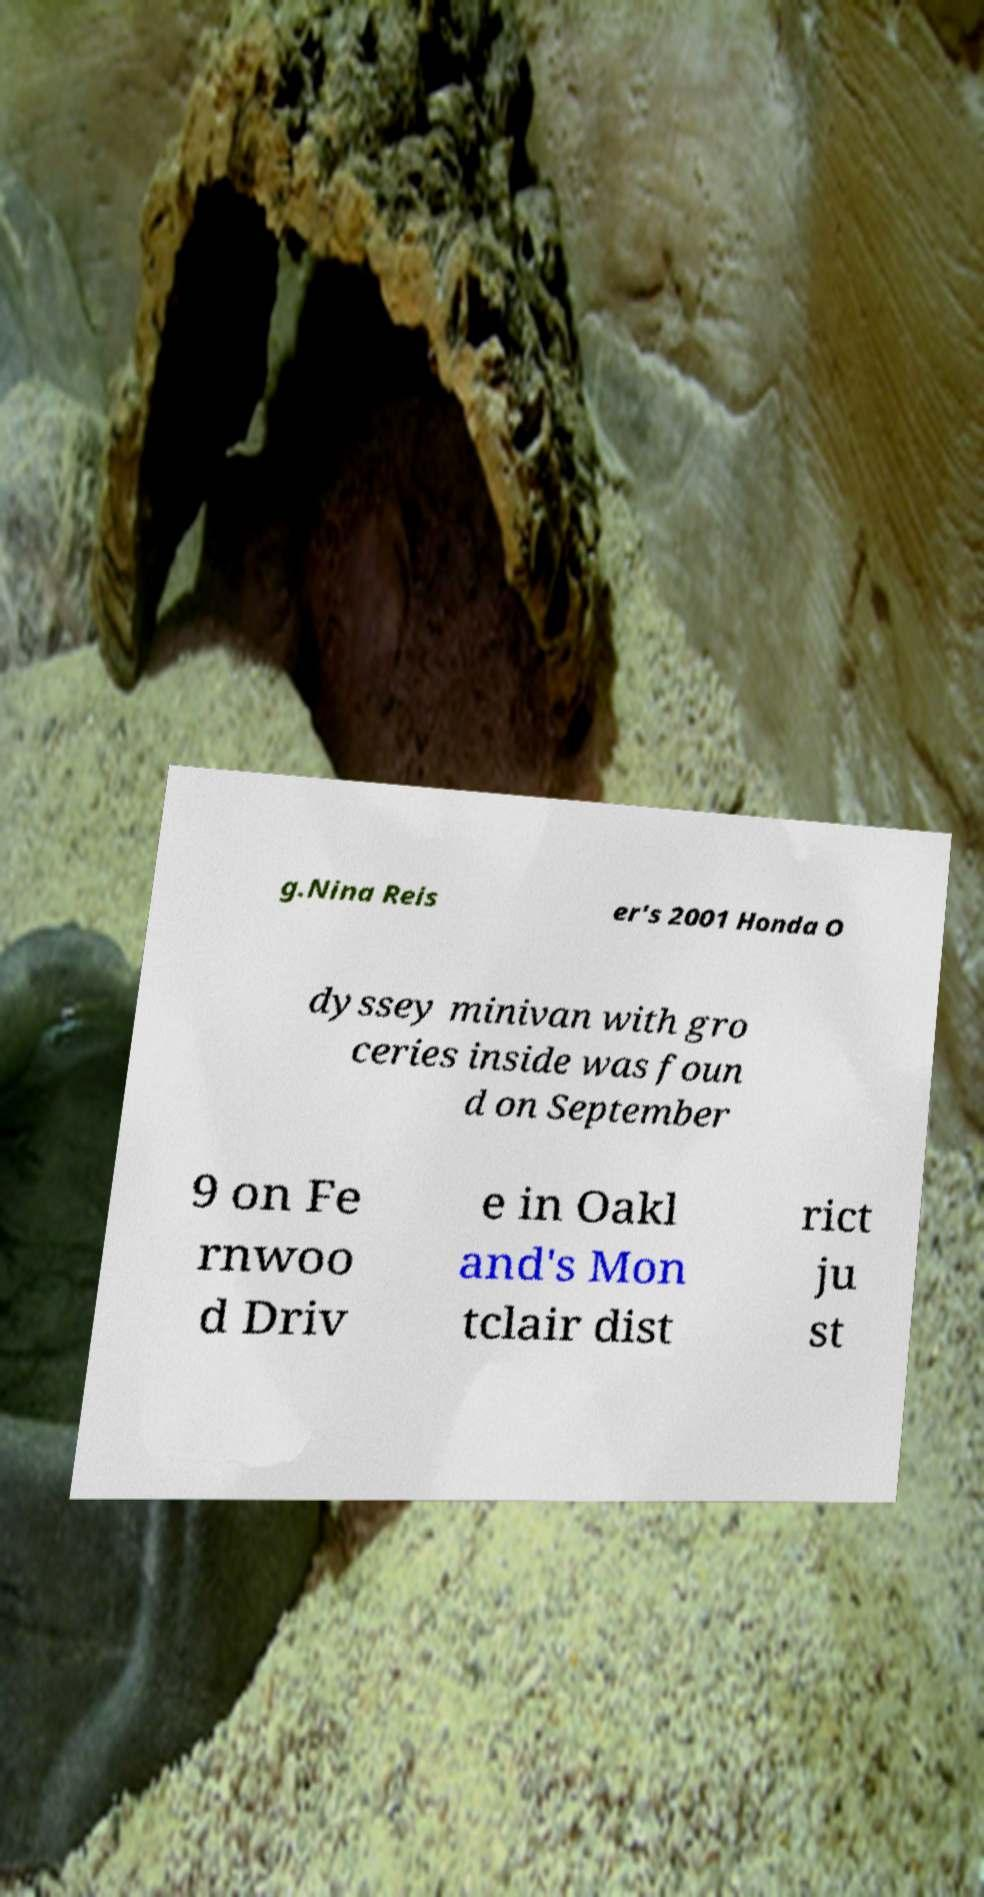Please read and relay the text visible in this image. What does it say? g.Nina Reis er's 2001 Honda O dyssey minivan with gro ceries inside was foun d on September 9 on Fe rnwoo d Driv e in Oakl and's Mon tclair dist rict ju st 